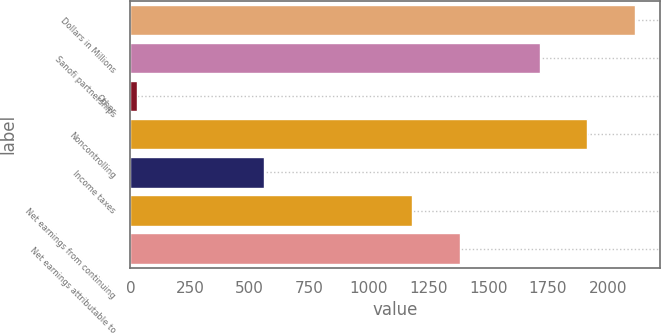Convert chart. <chart><loc_0><loc_0><loc_500><loc_500><bar_chart><fcel>Dollars in Millions<fcel>Sanofi partnerships<fcel>Other<fcel>Noncontrolling<fcel>Income taxes<fcel>Net earnings from continuing<fcel>Net earnings attributable to<nl><fcel>2113.6<fcel>1717<fcel>26<fcel>1915.3<fcel>562<fcel>1181<fcel>1379.3<nl></chart> 